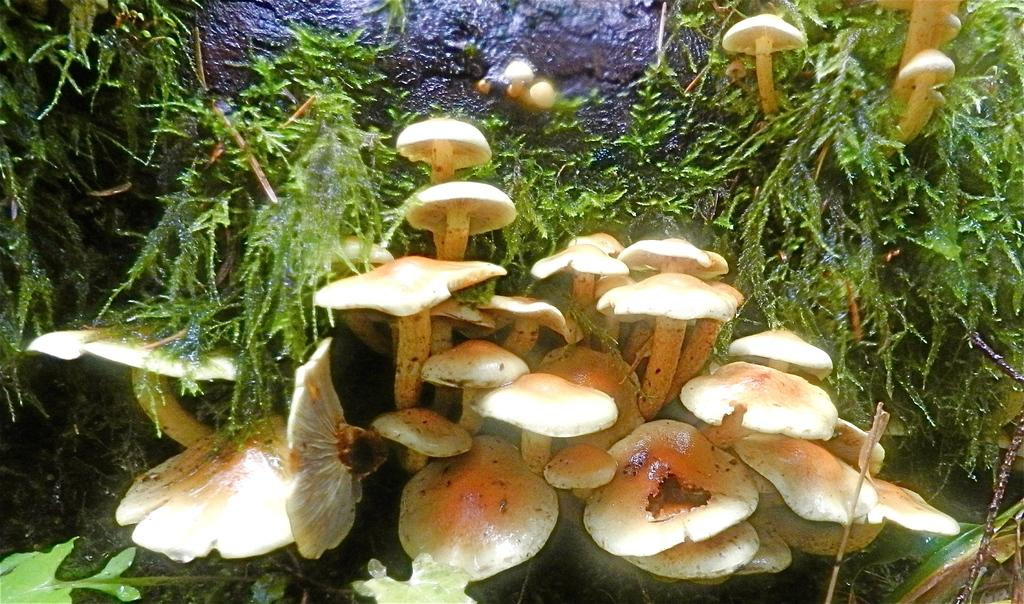What type of vegetation is present in the image? There are mushrooms and trees in the image. Can you describe the natural setting in the image? The image features a natural setting with mushrooms, trees, and a rock visible in the background. Who is the expert on mushrooms in the image? There is no expert on mushrooms present in the image. Can you tell me how many snails are crawling on the mushrooms in the image? There are no snails visible in the image; it only features mushrooms and trees. 